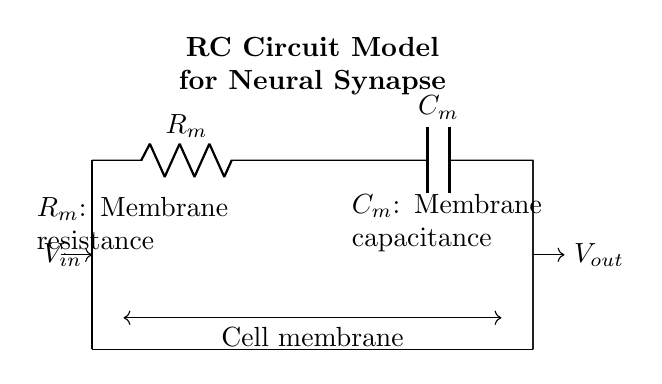What is the total resistance in this circuit? The total resistance in the circuit is given as the value for \( R_m \), which represents the membrane resistance in this model. Therefore, it can be directly referred to as \( R_m \).
Answer: R_m What does \( C_m \) represent in this circuit? \( C_m \) is labeled in the diagram and represents the membrane capacitance, which is associated with the ability of the cell membrane to store charge.
Answer: Membrane capacitance How many components are in the circuit diagram? The diagram includes two components: a resistor represented by \( R_m \) and a capacitor represented by \( C_m \). The total number of components is therefore two.
Answer: 2 What is the input voltage labeled as in the circuit? The input voltage is indicated by the arrow and is labeled as \( V_{in} \) in the diagram, which signifies the voltage applied to the circuit.
Answer: V_in Which component is responsible for storing charge in this RC circuit? The component responsible for storing charge in this circuit is the capacitor, represented as \( C_m \). This is due to its inherent property to hold an electric charge when a voltage is applied.
Answer: C_m What type of circuit does this diagram illustrate? This diagram illustrates a resistor-capacitor circuit model, specifically designed to resemble a neural synapse, reflecting how synaptic connections may behave electrically.
Answer: RC Circuit Model How do the components connect to form the circuit? The components \( R_m \) and \( C_m \) are connected in series: the current flows from the input voltage source through the resistor before reaching the capacitor, completing the loop back to the source.
Answer: In series 